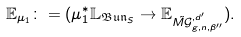Convert formula to latex. <formula><loc_0><loc_0><loc_500><loc_500>\mathbb { E } _ { \mu _ { 1 } } \colon = ( \mu _ { 1 } ^ { * } \mathbb { L } _ { \mathfrak { B u n } _ { S } } \rightarrow \mathbb { E } _ { \tilde { M \mathcal { G } } ^ { , d ^ { \prime } } _ { g , n , { \beta ^ { \prime \prime } } } } ) .</formula> 